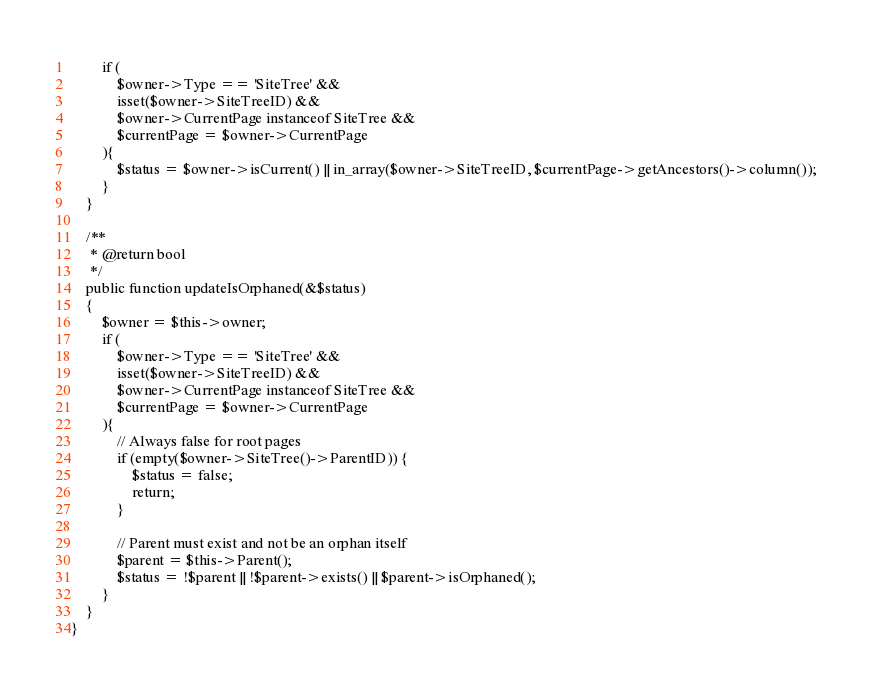Convert code to text. <code><loc_0><loc_0><loc_500><loc_500><_PHP_>        if (
            $owner->Type == 'SiteTree' &&
            isset($owner->SiteTreeID) &&
            $owner->CurrentPage instanceof SiteTree &&
            $currentPage = $owner->CurrentPage
        ){
            $status = $owner->isCurrent() || in_array($owner->SiteTreeID, $currentPage->getAncestors()->column());
        }
    }

    /**
     * @return bool
     */
    public function updateIsOrphaned(&$status)
    {
        $owner = $this->owner;
        if (
            $owner->Type == 'SiteTree' &&
            isset($owner->SiteTreeID) &&
            $owner->CurrentPage instanceof SiteTree &&
            $currentPage = $owner->CurrentPage
        ){
            // Always false for root pages
            if (empty($owner->SiteTree()->ParentID)) {
                $status = false;
                return;
            }

            // Parent must exist and not be an orphan itself
            $parent = $this->Parent();
            $status = !$parent || !$parent->exists() || $parent->isOrphaned();
        }
    }
}
</code> 